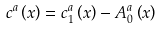<formula> <loc_0><loc_0><loc_500><loc_500>c ^ { a } \left ( x \right ) = c _ { 1 } ^ { a } \left ( x \right ) - A _ { 0 } ^ { a } \left ( x \right )</formula> 